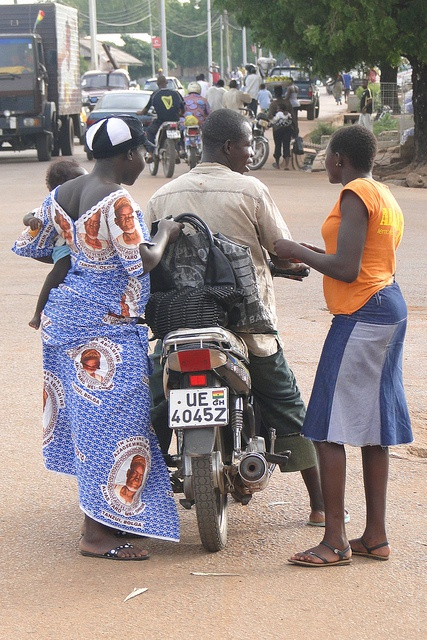Describe the objects in this image and their specific colors. I can see people in white, lightgray, darkgray, and blue tones, people in white, gray, black, darkgray, and lightgray tones, people in white, gray, maroon, and navy tones, motorcycle in white, gray, black, lightgray, and darkgray tones, and truck in white, gray, lightgray, and darkgray tones in this image. 